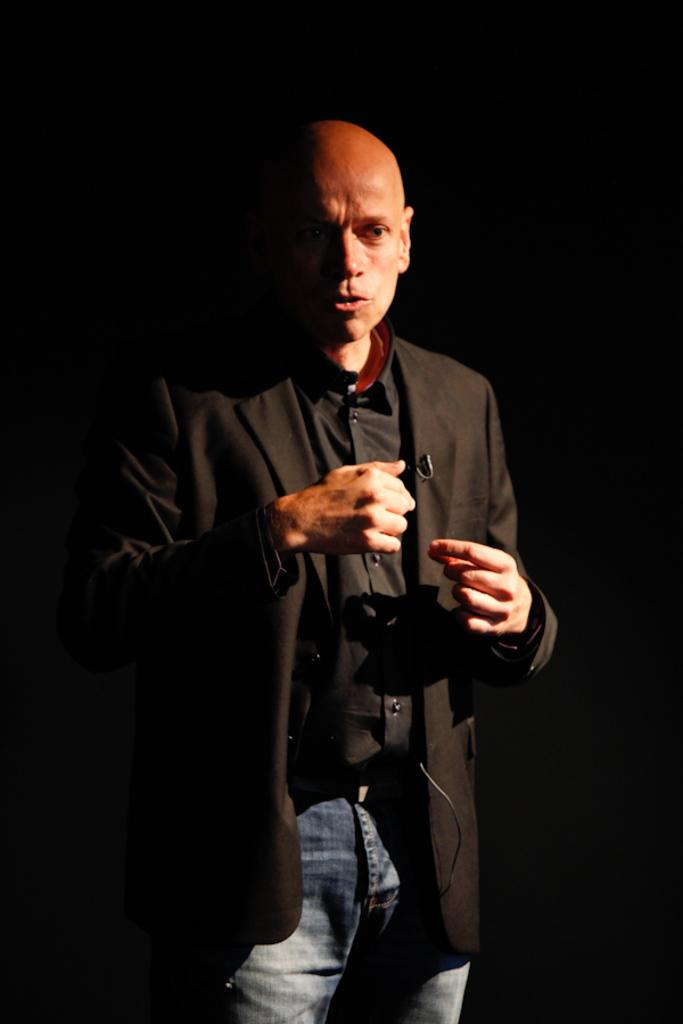Who or what is the main subject in the image? There is a person in the image. What can be observed about the background of the image? The background of the image is dark. What type of playground equipment can be seen in the image? There is no playground equipment present in the image. Is the person wearing a mitten in the image? The facts provided do not mention any specific clothing or accessories worn by the person, so it cannot be determined if they are wearing a mitten. 